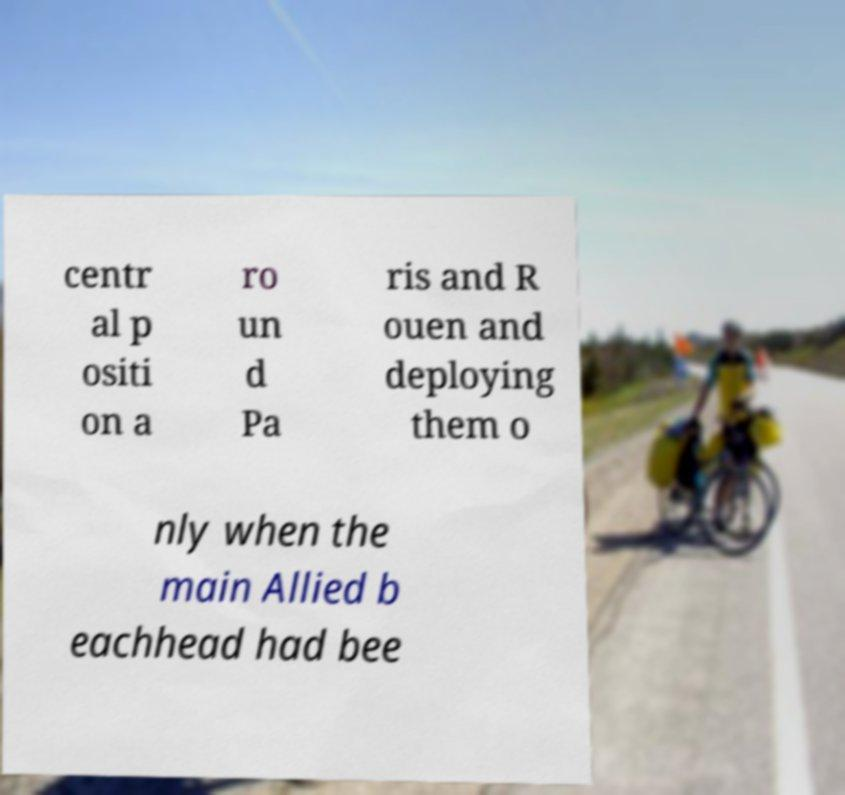Please identify and transcribe the text found in this image. centr al p ositi on a ro un d Pa ris and R ouen and deploying them o nly when the main Allied b eachhead had bee 